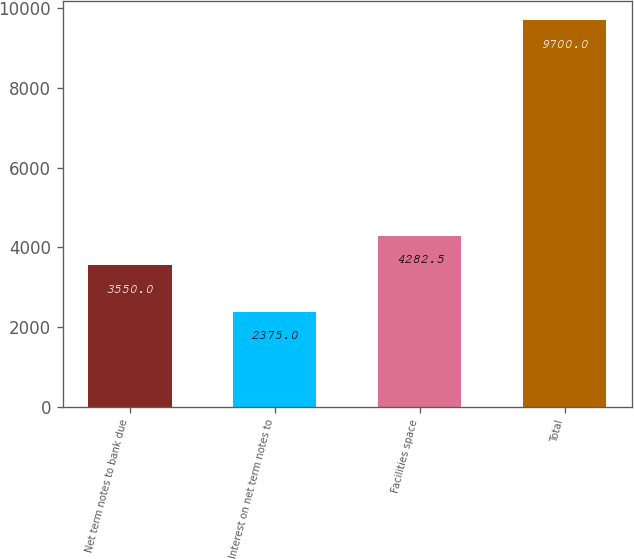Convert chart. <chart><loc_0><loc_0><loc_500><loc_500><bar_chart><fcel>Net term notes to bank due<fcel>Interest on net term notes to<fcel>Facilities space<fcel>Total<nl><fcel>3550<fcel>2375<fcel>4282.5<fcel>9700<nl></chart> 